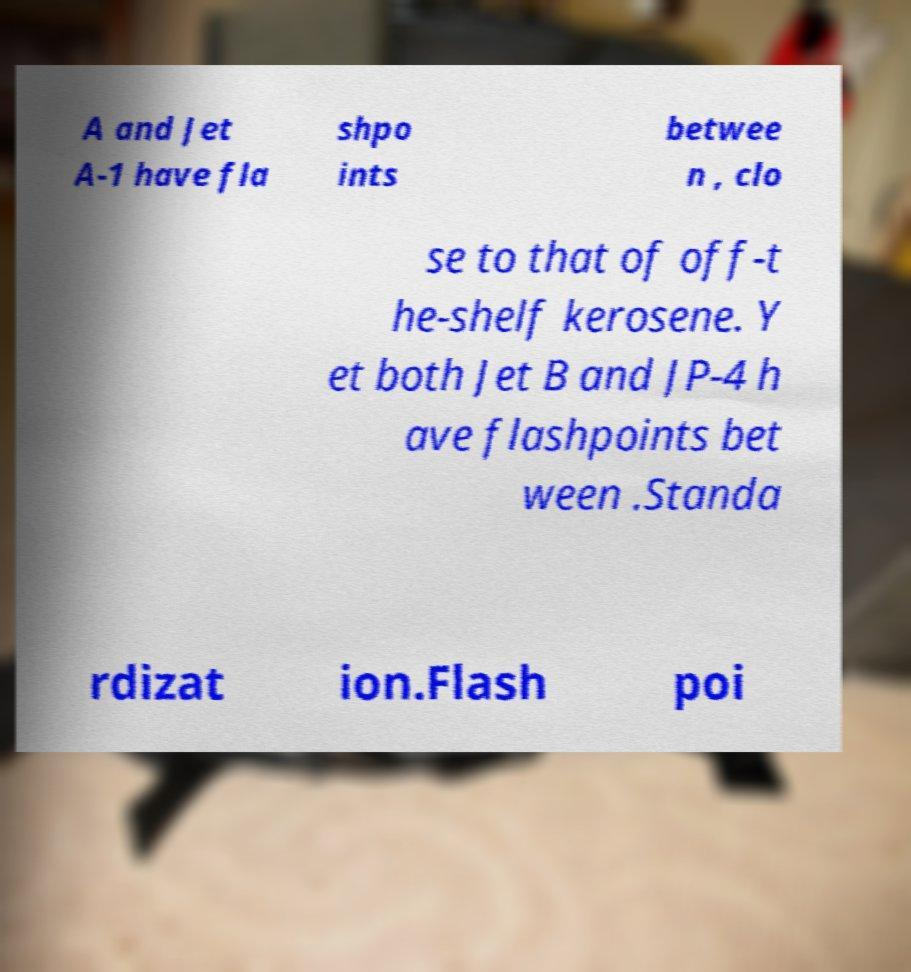Could you extract and type out the text from this image? A and Jet A-1 have fla shpo ints betwee n , clo se to that of off-t he-shelf kerosene. Y et both Jet B and JP-4 h ave flashpoints bet ween .Standa rdizat ion.Flash poi 